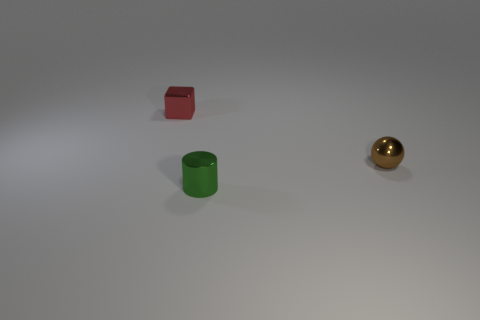Is there anything else that has the same color as the small cylinder?
Your response must be concise. No. There is a tiny shiny thing on the right side of the thing in front of the small brown ball; is there a small metallic sphere left of it?
Make the answer very short. No. What is the color of the tiny block?
Offer a very short reply. Red. Are there any cylinders in front of the brown metallic ball?
Provide a short and direct response. Yes. How many other objects are the same material as the block?
Make the answer very short. 2. What color is the object that is behind the tiny shiny thing to the right of the small object that is in front of the small ball?
Give a very brief answer. Red. The metallic thing right of the thing in front of the tiny brown metal thing is what shape?
Provide a short and direct response. Sphere. Are there more metal things that are left of the cylinder than small red metal cylinders?
Make the answer very short. Yes. Is there a large gray metallic thing of the same shape as the red metal object?
Ensure brevity in your answer.  No. How many objects are small metal things that are behind the small cylinder or small yellow metal things?
Offer a terse response. 2. 